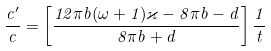Convert formula to latex. <formula><loc_0><loc_0><loc_500><loc_500>\frac { c ^ { \prime } } { c } = \left [ \frac { 1 2 \pi b ( \omega + 1 ) \varkappa - 8 \pi b - d } { 8 \pi b + d } \right ] \frac { 1 } { t }</formula> 